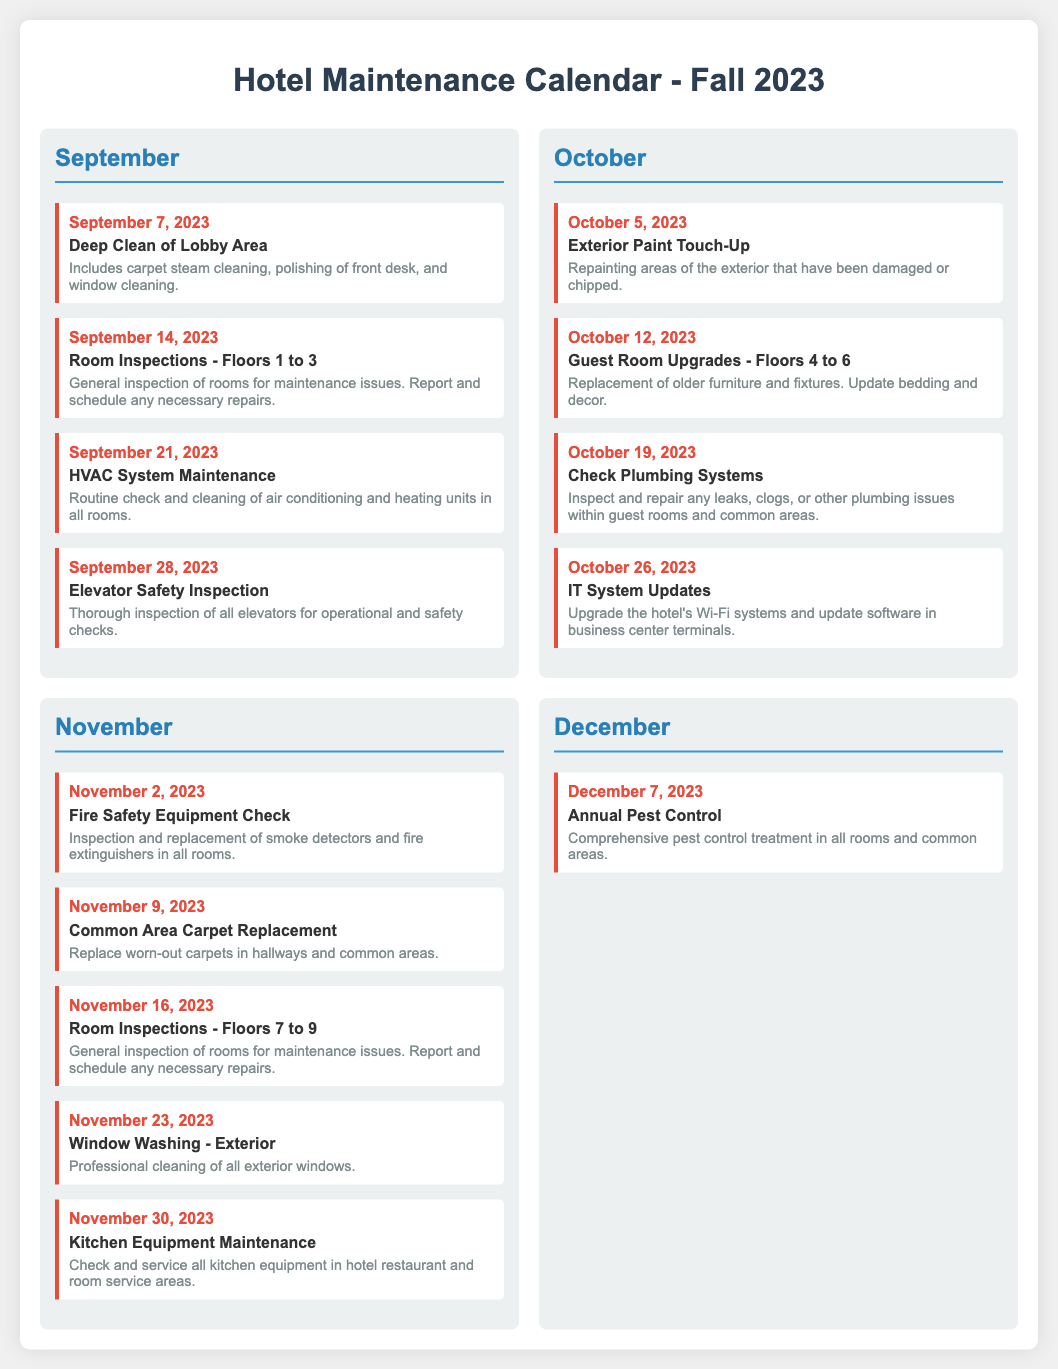What is the first maintenance task scheduled in September? The first task is "Deep Clean of Lobby Area" on September 7, 2023.
Answer: Deep Clean of Lobby Area How many floors will have room inspections in September? Room inspections are scheduled for Floors 1 to 3 in September.
Answer: Floors 1 to 3 What type of maintenance is scheduled on October 12, 2023? The maintenance scheduled is "Guest Room Upgrades - Floors 4 to 6".
Answer: Guest Room Upgrades - Floors 4 to 6 Which maintenance task involves plumbing? The task on October 19, 2023, is related to plumbing systems.
Answer: Check Plumbing Systems What is being replaced on November 9, 2023? The maintenance task involves "Common Area Carpet Replacement".
Answer: Common Area Carpet Replacement How many total maintenance tasks are listed for November? There are five maintenance tasks scheduled for November.
Answer: Five What is the last maintenance task in the calendar? The last task scheduled is "Annual Pest Control" on December 7, 2023.
Answer: Annual Pest Control Where will the elevator safety inspection take place? The elevator safety inspection will check all elevators in the hotel.
Answer: All elevators What is the main focus of the task on September 21, 2023? The focus is on maintaining the HVAC system through routine checks and cleaning.
Answer: HVAC System Maintenance 